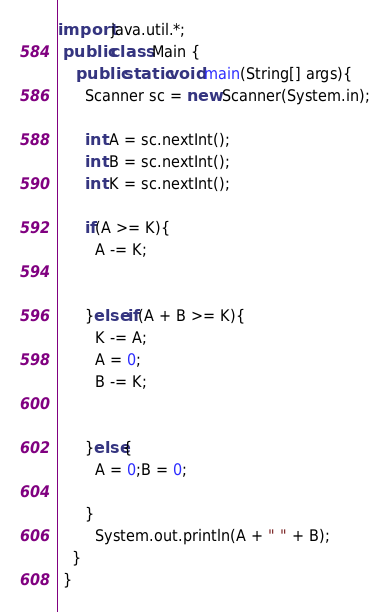<code> <loc_0><loc_0><loc_500><loc_500><_Java_>import java.util.*;
 public class Main {
	public static void main(String[] args){
      Scanner sc = new Scanner(System.in);

      int A = sc.nextInt();
      int B = sc.nextInt();
      int K = sc.nextInt();

      if(A >= K){
        A -= K;
       

      }else if(A + B >= K){
        K -= A;
        A = 0;
        B -= K;
      

      }else{
        A = 0;B = 0;
       
      }
        System.out.println(A + " " + B);
   }
 }</code> 